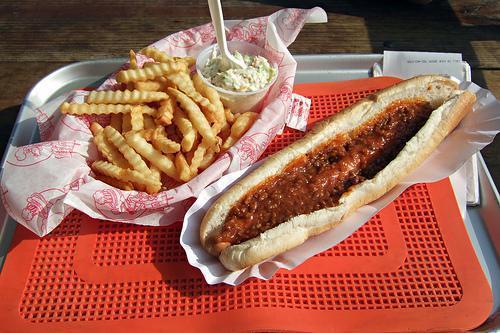How many different foods are there?
Give a very brief answer. 3. How many of the foods in this image can be eaten with one's fingers?
Give a very brief answer. 2. 